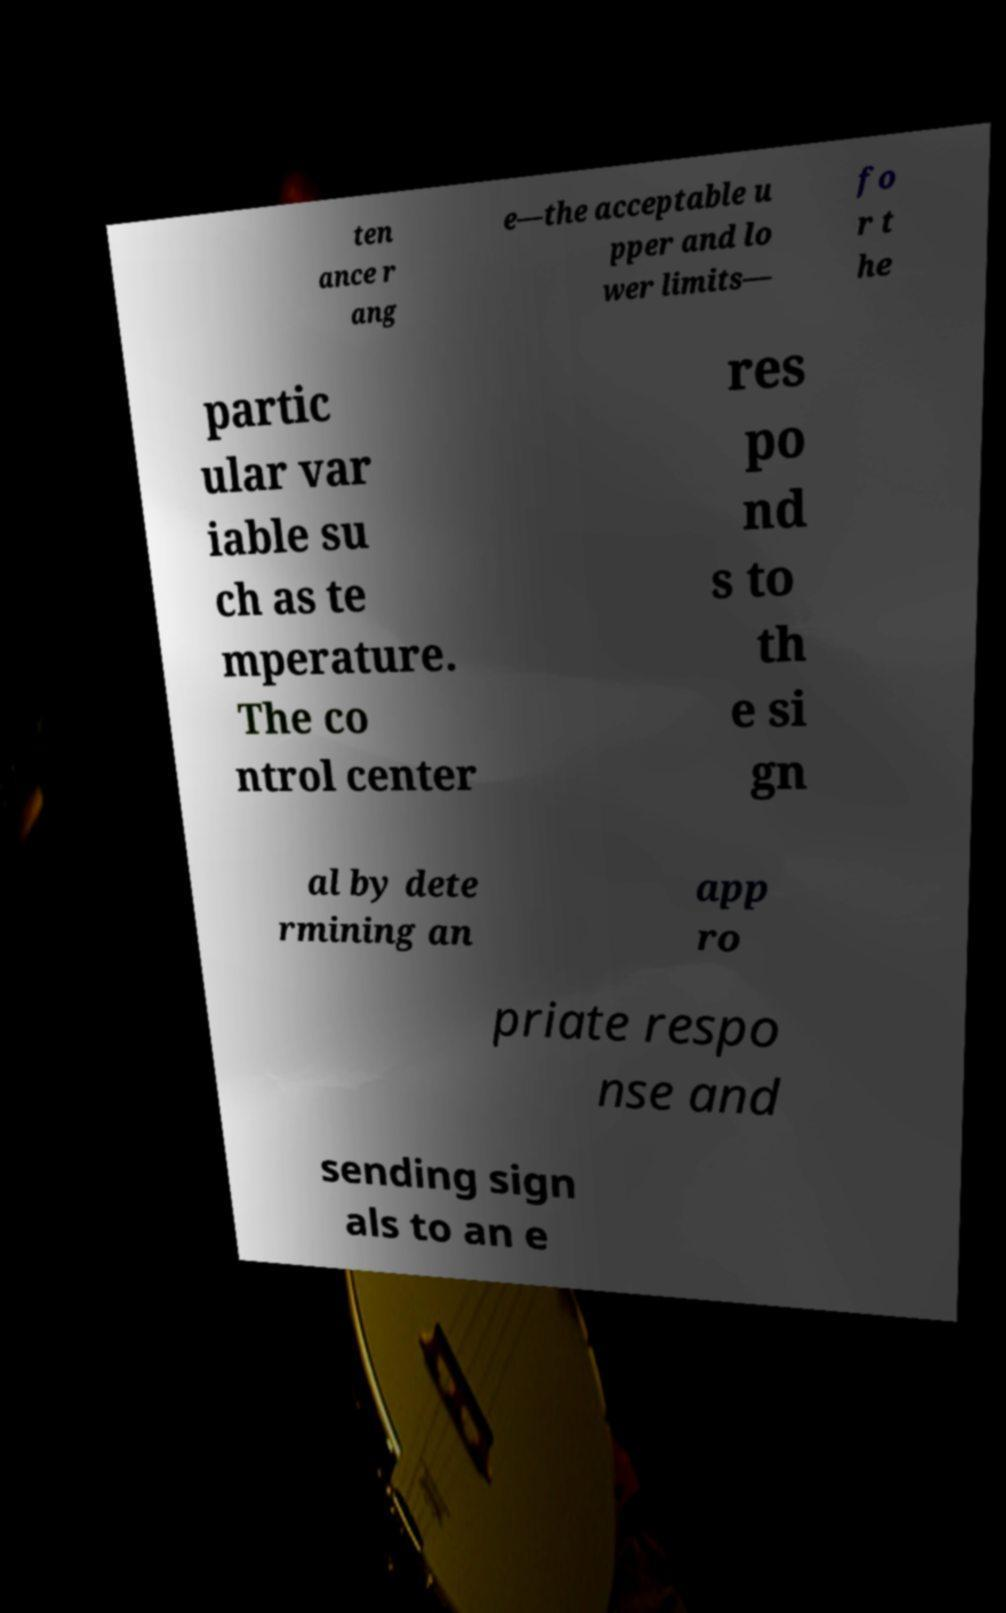What messages or text are displayed in this image? I need them in a readable, typed format. ten ance r ang e—the acceptable u pper and lo wer limits— fo r t he partic ular var iable su ch as te mperature. The co ntrol center res po nd s to th e si gn al by dete rmining an app ro priate respo nse and sending sign als to an e 